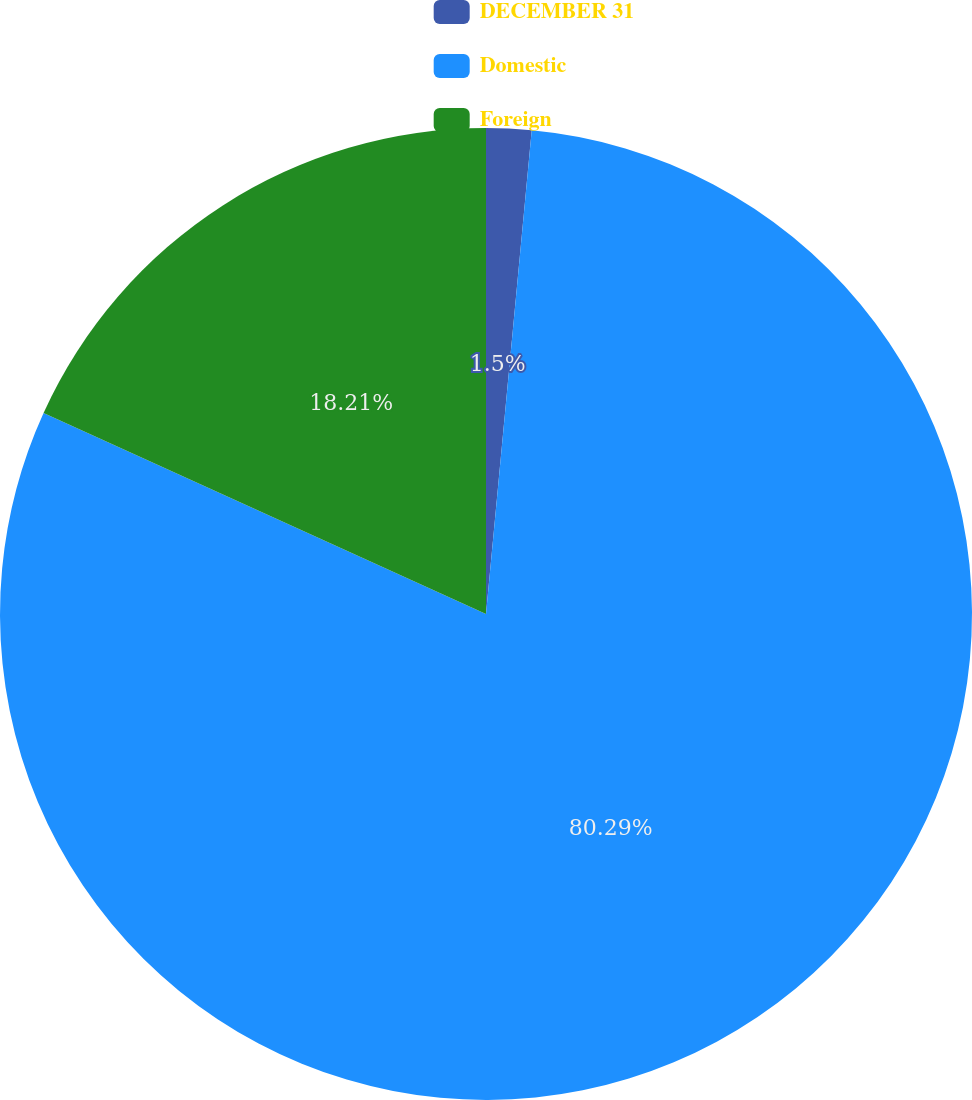Convert chart. <chart><loc_0><loc_0><loc_500><loc_500><pie_chart><fcel>DECEMBER 31<fcel>Domestic<fcel>Foreign<nl><fcel>1.5%<fcel>80.29%<fcel>18.21%<nl></chart> 